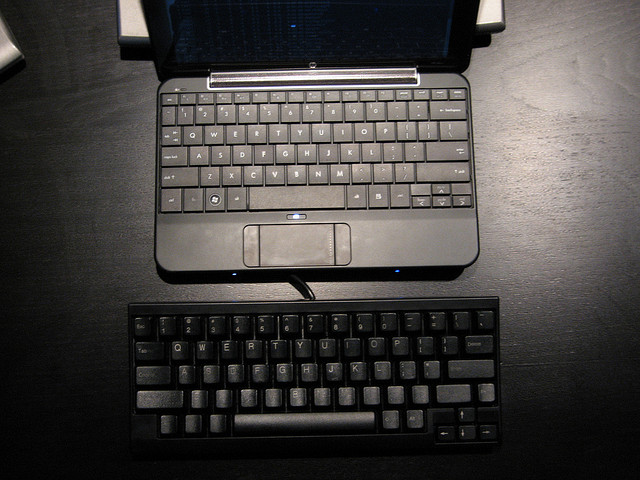What could be the purpose of setting up an external keyboard in addition to the laptop’s built-in one? Using an external keyboard alongside the laptop’s built-in one could have several purposes. It can provide a more comfortable typing position, allow for a full-sized keyboard layout which can enhance typing efficiency, or cater to specific ergonomic needs. Sometimes, users with dual monitor setups also prefer a separate keyboard if the laptop is placed at a distance or elevated for better screen viewing.  Could the second keyboard suggest that the user is a programmer or gamer? Certainly, the presence of an external keyboard could indicate that the user engages in activities like programming or gaming. Programmers often require a high-quality keyboard for long coding sessions that are comfortable and minimize the risk of repetitive strain injuries. Gamers similarly benefit from keyboards with specialized keys and responsive switches that improve their playing experience. 